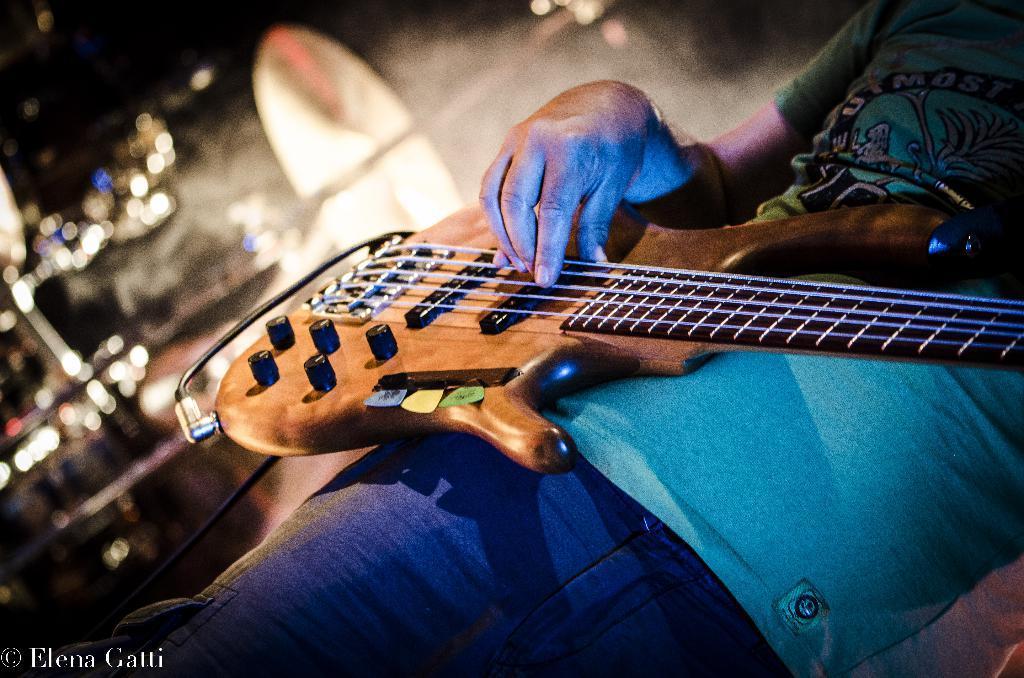In one or two sentences, can you explain what this image depicts? He is standing and his wearing guitar. We can see in background lights. 